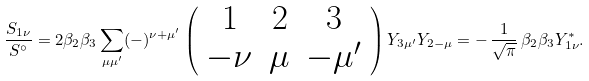<formula> <loc_0><loc_0><loc_500><loc_500>\frac { S _ { 1 \nu } } { S ^ { \circ } } = 2 \beta _ { 2 } \beta _ { 3 } \sum _ { \mu \mu ^ { \prime } } ( - ) ^ { \nu + \mu ^ { \prime } } \left ( \begin{array} { c c c } 1 & 2 & 3 \\ - \nu & \mu & - \mu ^ { \prime } \end{array} \right ) Y _ { 3 \mu ^ { \prime } } Y _ { 2 - \mu } = - \, \frac { 1 } { \sqrt { \pi } } \, \beta _ { 2 } \beta _ { 3 } Y ^ { \ast } _ { 1 \nu } .</formula> 